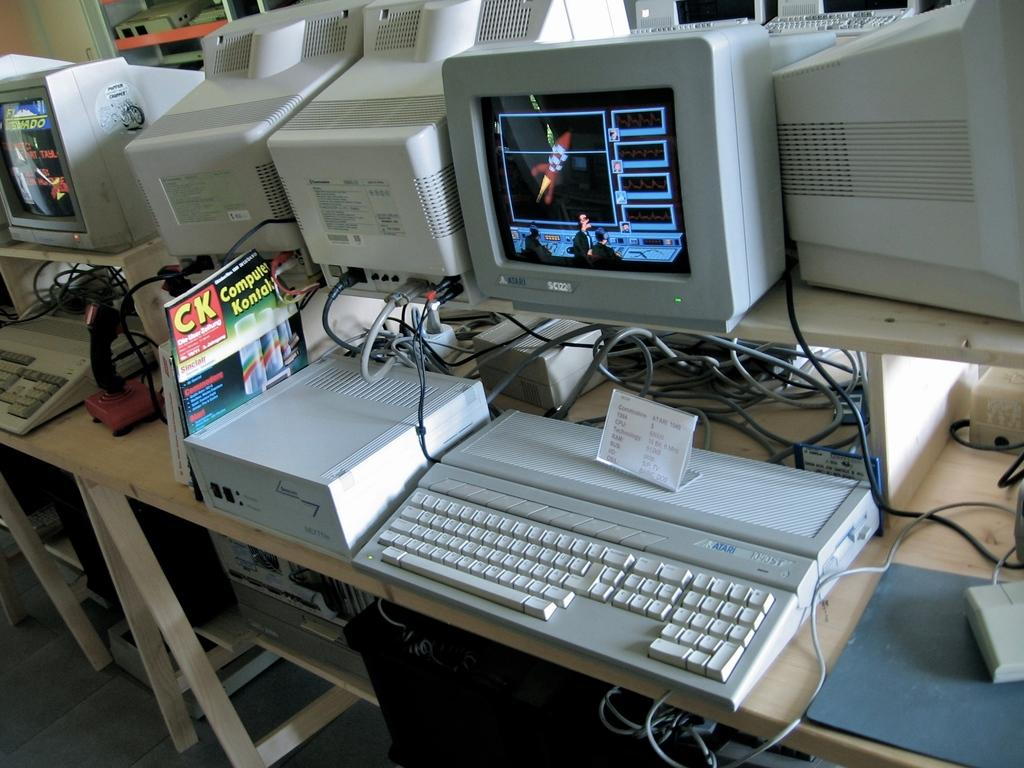<image>
Give a short and clear explanation of the subsequent image. An Atari computer with the keyboard and everything. 